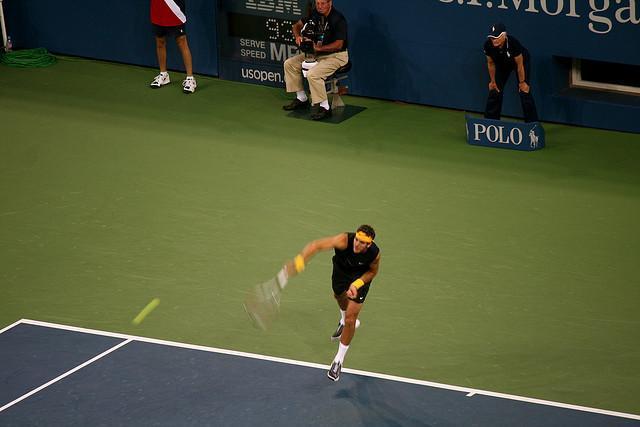How many people are in the picture?
Give a very brief answer. 4. How many men are in pants?
Give a very brief answer. 2. How many people are there?
Give a very brief answer. 4. How many cars are to the right of the pole?
Give a very brief answer. 0. 